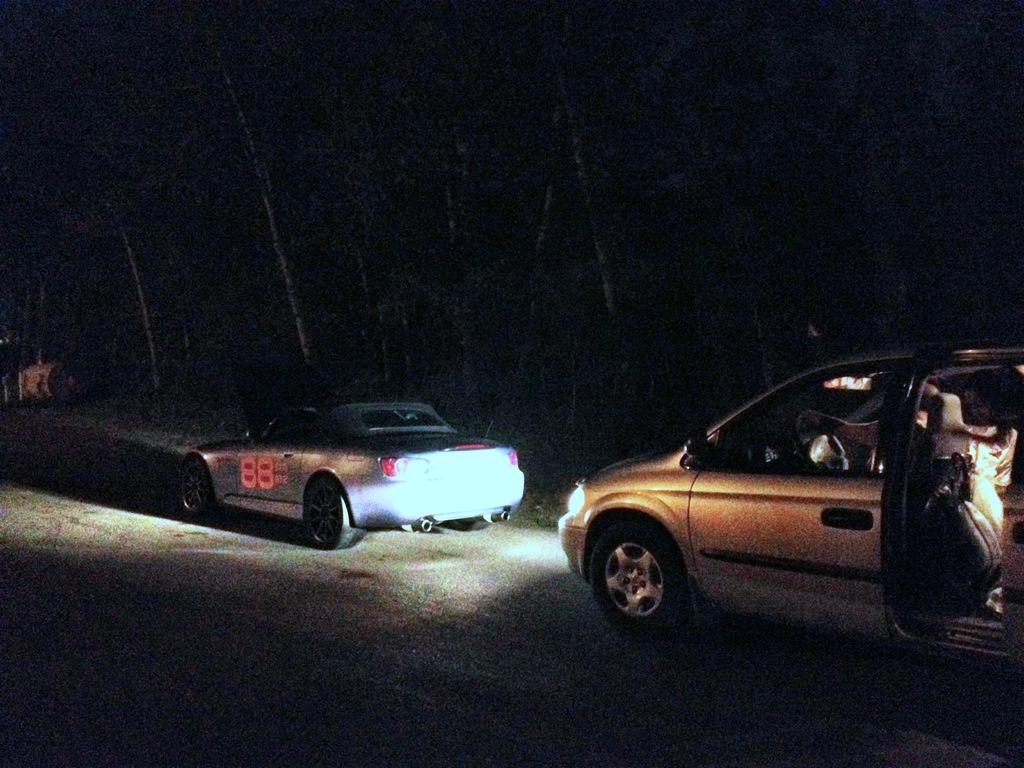How many cars are visible in the image? There are two cars in the image. Where are the cars located? The cars are on the road. What can be seen in the background of the image? There are trees in the background of the image. What type of hat is the fruit wearing in the image? There is no fruit or hat present in the image. What game are the cars playing in the image? The cars are not playing a game in the image; they are simply on the road. 